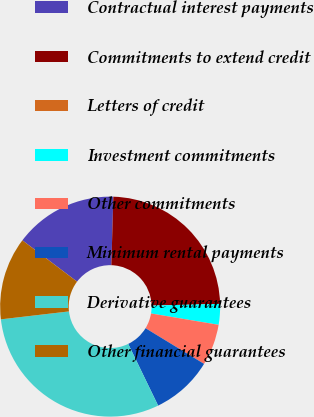<chart> <loc_0><loc_0><loc_500><loc_500><pie_chart><fcel>Contractual interest payments<fcel>Commitments to extend credit<fcel>Letters of credit<fcel>Investment commitments<fcel>Other commitments<fcel>Minimum rental payments<fcel>Derivative guarantees<fcel>Other financial guarantees<nl><fcel>15.17%<fcel>24.14%<fcel>0.0%<fcel>3.04%<fcel>6.07%<fcel>9.1%<fcel>30.34%<fcel>12.14%<nl></chart> 